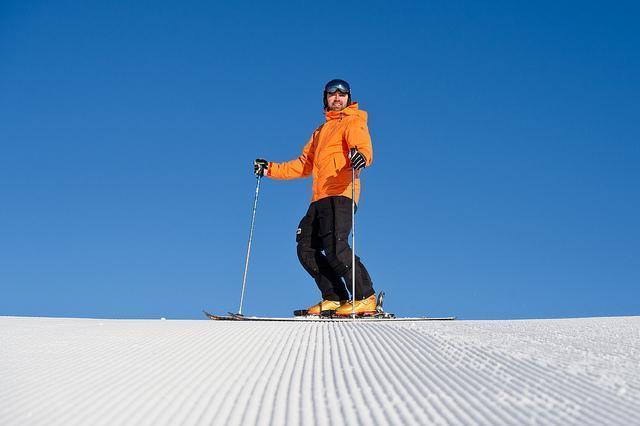How many benches are in the scene?
Give a very brief answer. 0. 